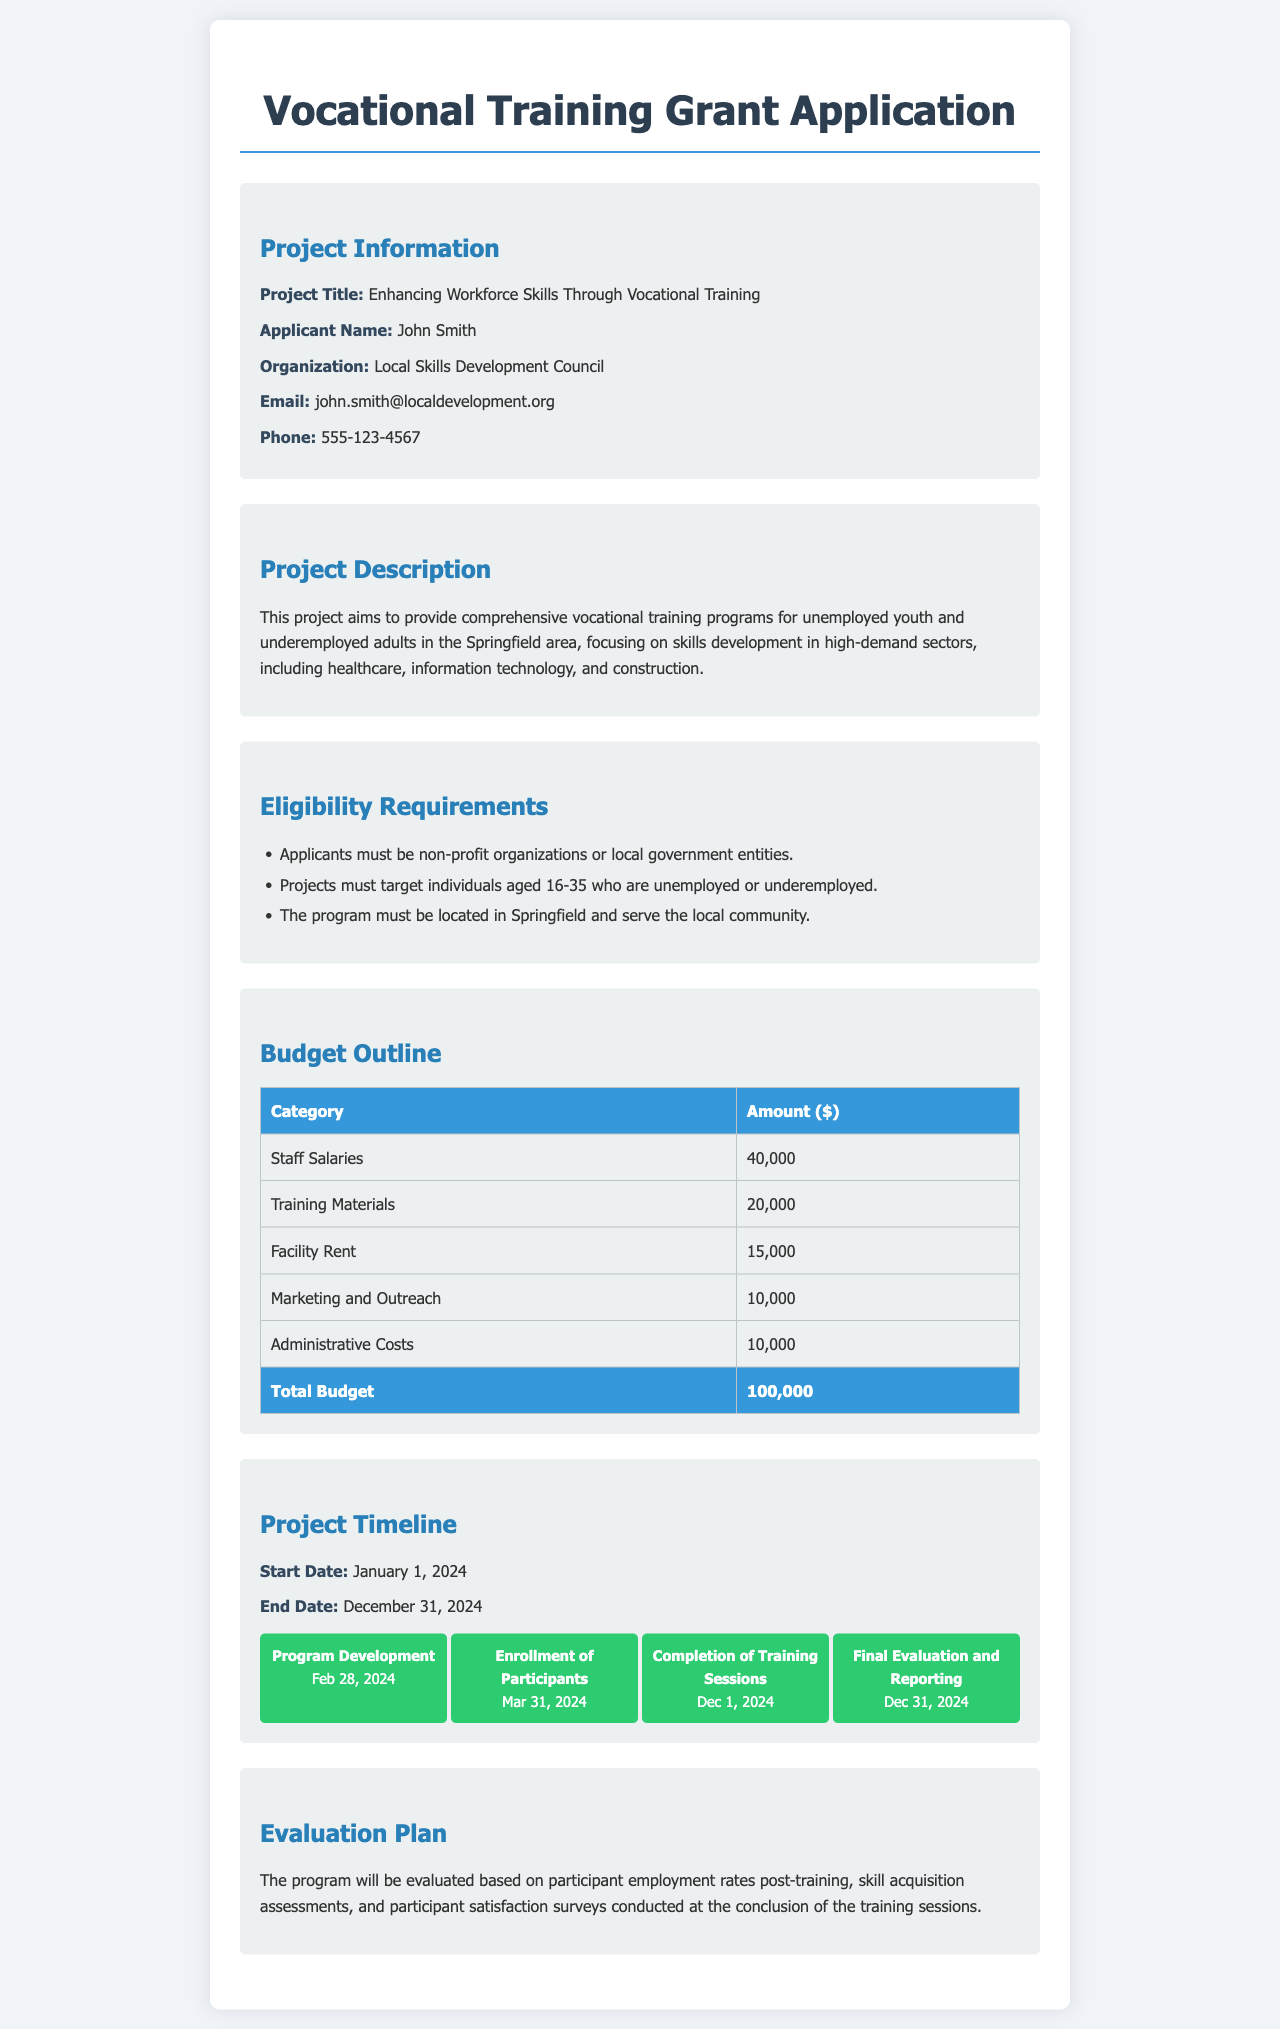what is the project title? The project title is stated in the "Project Information" section of the document.
Answer: Enhancing Workforce Skills Through Vocational Training who is the applicant? The applicant's name is provided in the "Project Information" section of the document.
Answer: John Smith what is the total budget for the project? The total budget is summarized in the "Budget Outline" section at the end of the respective table.
Answer: 100,000 what is the start date of the project? The start date of the project is mentioned in the "Project Timeline" section of the document.
Answer: January 1, 2024 which age group does the program target? The eligibility requirements specify the age group targeted by the program.
Answer: 16-35 what is the purpose of the project? The purpose of the project is described in the "Project Description" section.
Answer: Provide comprehensive vocational training programs who will evaluate the program? The evaluation is based on participant outcomes, which is outlined in the "Evaluation Plan" section.
Answer: Local Skills Development Council what is the first milestone in the project timeline? The first milestone is listed in the "Project Timeline" section.
Answer: Program Development how much is allocated for training materials? The budget outline specifies the amount allocated for training materials in the respective table.
Answer: 20,000 